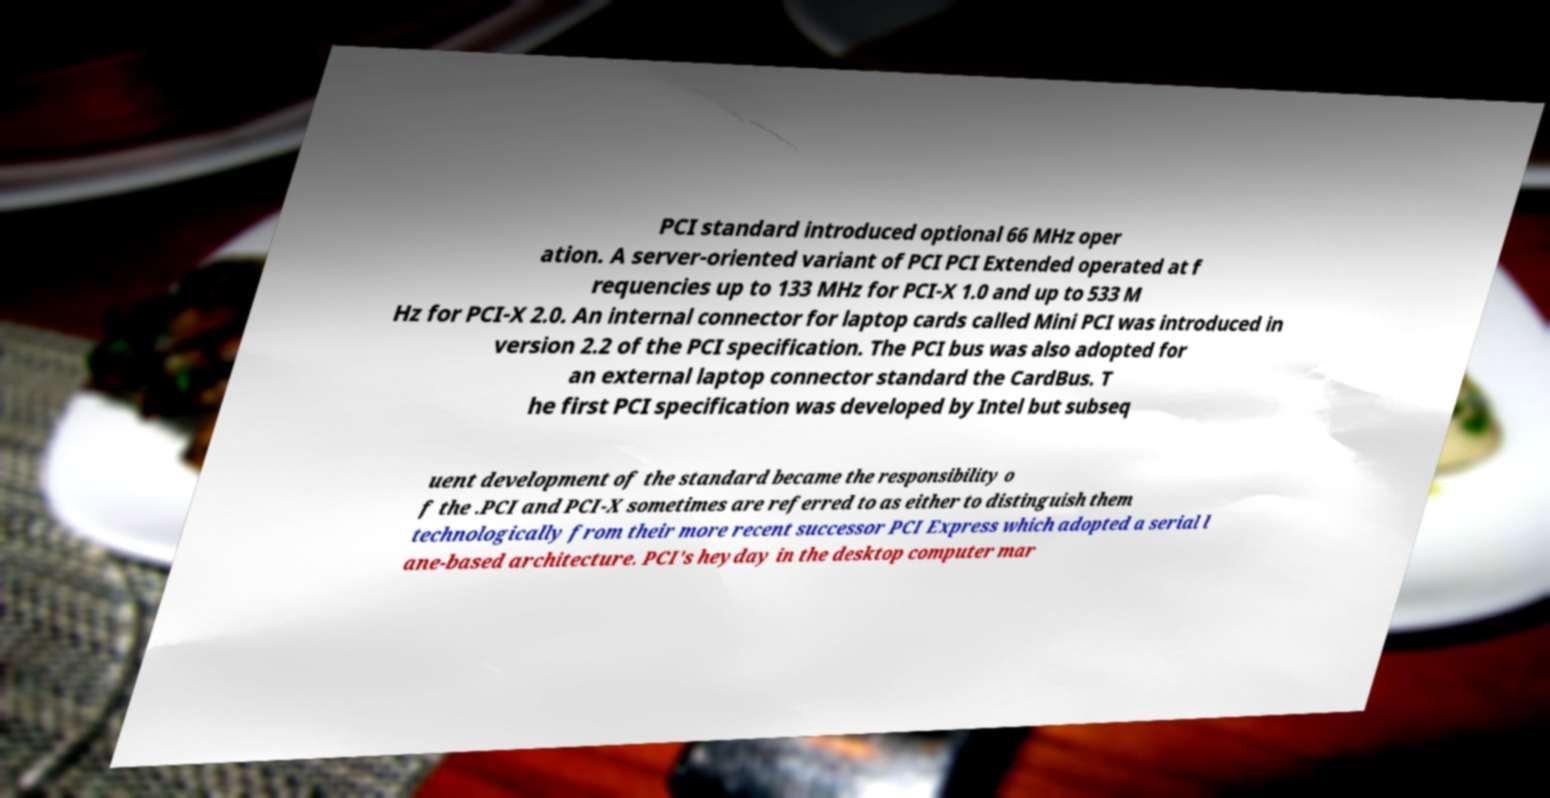For documentation purposes, I need the text within this image transcribed. Could you provide that? PCI standard introduced optional 66 MHz oper ation. A server-oriented variant of PCI PCI Extended operated at f requencies up to 133 MHz for PCI-X 1.0 and up to 533 M Hz for PCI-X 2.0. An internal connector for laptop cards called Mini PCI was introduced in version 2.2 of the PCI specification. The PCI bus was also adopted for an external laptop connector standard the CardBus. T he first PCI specification was developed by Intel but subseq uent development of the standard became the responsibility o f the .PCI and PCI-X sometimes are referred to as either to distinguish them technologically from their more recent successor PCI Express which adopted a serial l ane-based architecture. PCI's heyday in the desktop computer mar 